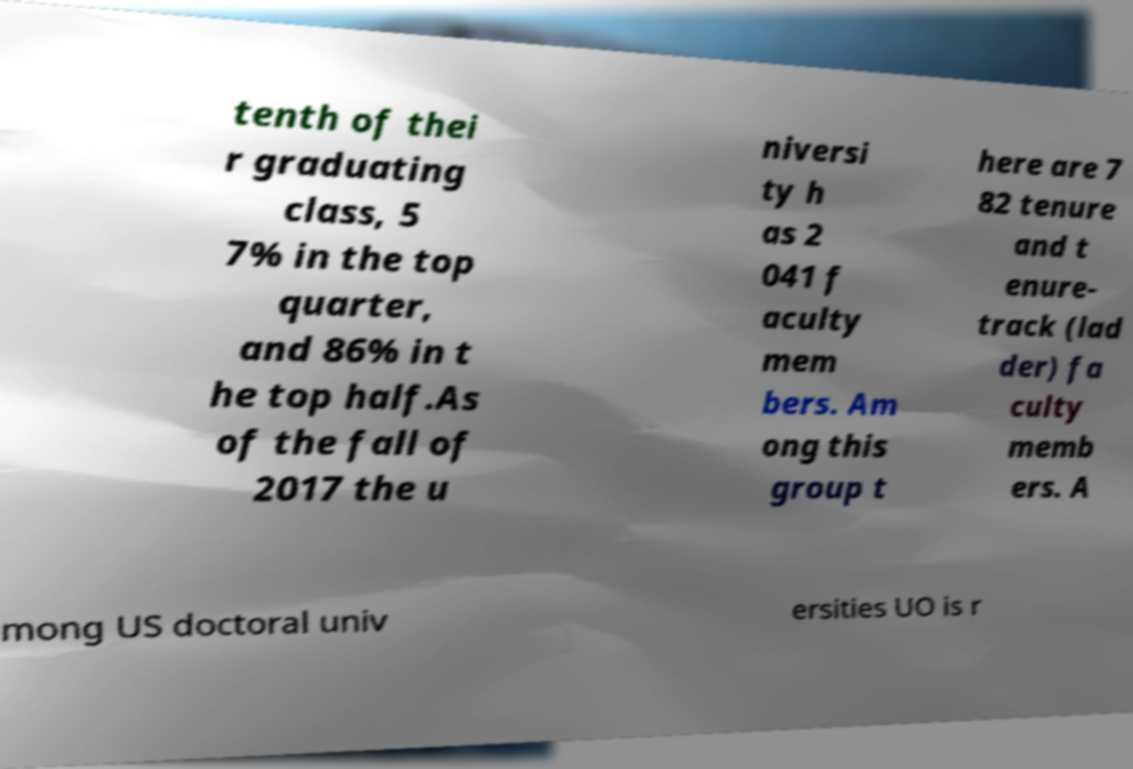What messages or text are displayed in this image? I need them in a readable, typed format. tenth of thei r graduating class, 5 7% in the top quarter, and 86% in t he top half.As of the fall of 2017 the u niversi ty h as 2 041 f aculty mem bers. Am ong this group t here are 7 82 tenure and t enure- track (lad der) fa culty memb ers. A mong US doctoral univ ersities UO is r 